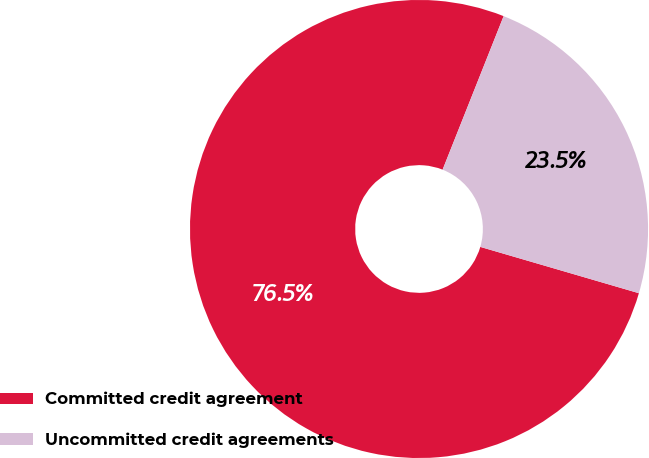Convert chart to OTSL. <chart><loc_0><loc_0><loc_500><loc_500><pie_chart><fcel>Committed credit agreement<fcel>Uncommitted credit agreements<nl><fcel>76.5%<fcel>23.5%<nl></chart> 